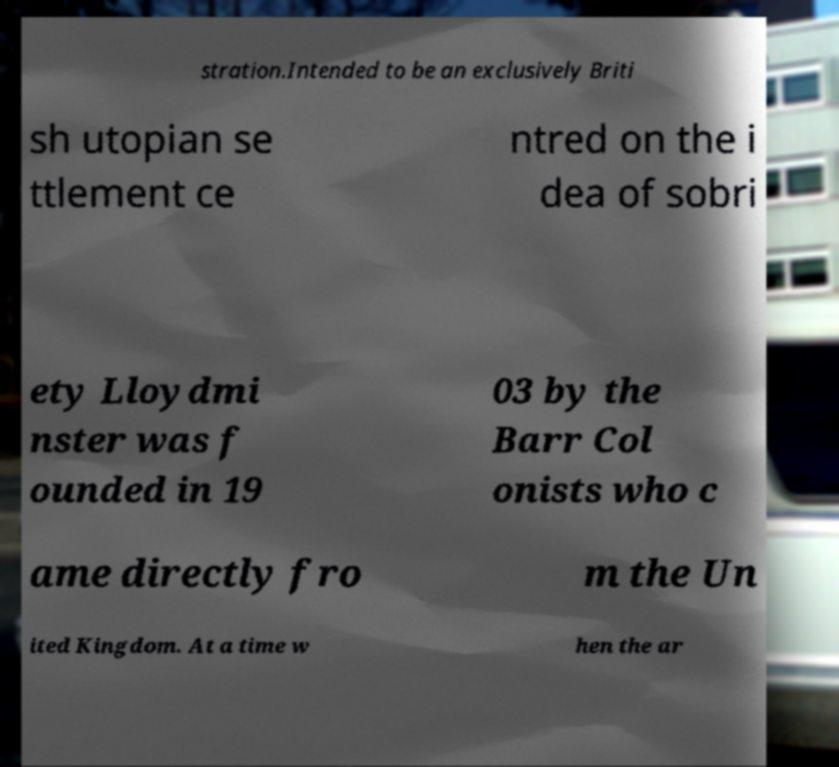Can you accurately transcribe the text from the provided image for me? stration.Intended to be an exclusively Briti sh utopian se ttlement ce ntred on the i dea of sobri ety Lloydmi nster was f ounded in 19 03 by the Barr Col onists who c ame directly fro m the Un ited Kingdom. At a time w hen the ar 